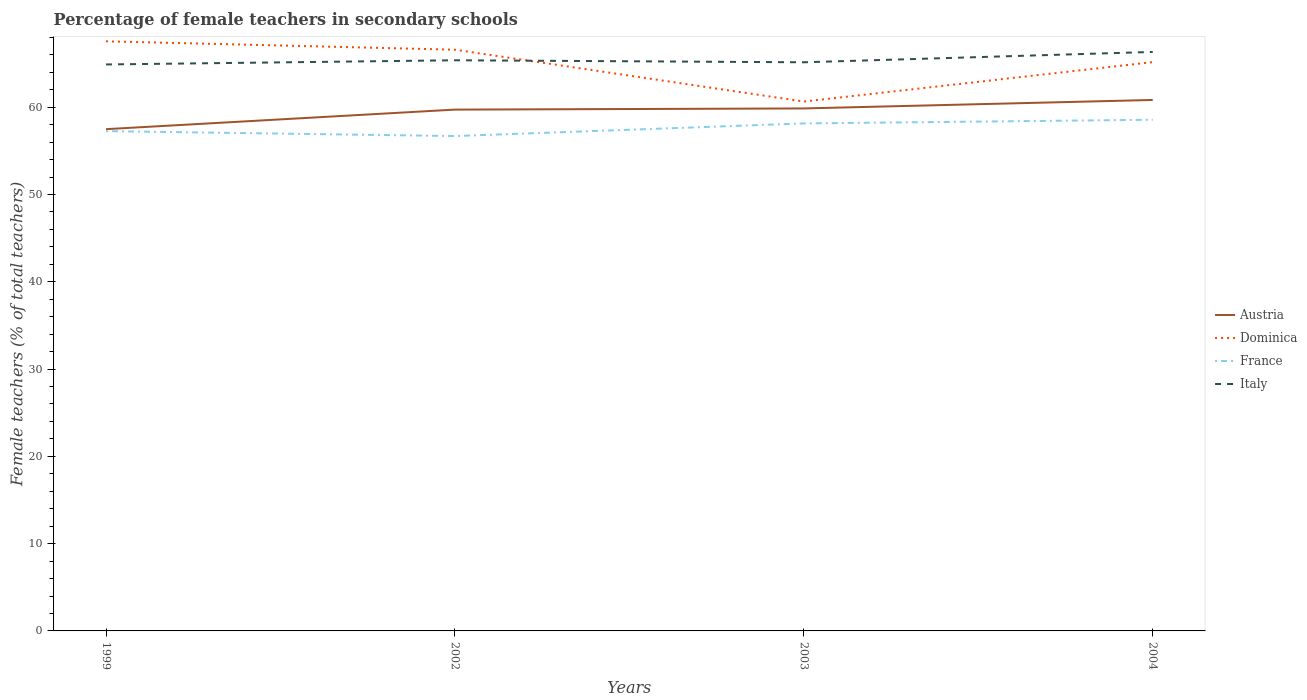Does the line corresponding to Dominica intersect with the line corresponding to Italy?
Make the answer very short. Yes. Across all years, what is the maximum percentage of female teachers in Italy?
Your response must be concise. 64.9. In which year was the percentage of female teachers in France maximum?
Your response must be concise. 2002. What is the total percentage of female teachers in France in the graph?
Ensure brevity in your answer.  -1.3. What is the difference between the highest and the second highest percentage of female teachers in France?
Ensure brevity in your answer.  1.87. Is the percentage of female teachers in Dominica strictly greater than the percentage of female teachers in Austria over the years?
Ensure brevity in your answer.  No. How many lines are there?
Keep it short and to the point. 4. Does the graph contain grids?
Ensure brevity in your answer.  No. Where does the legend appear in the graph?
Provide a short and direct response. Center right. How many legend labels are there?
Offer a very short reply. 4. What is the title of the graph?
Offer a very short reply. Percentage of female teachers in secondary schools. What is the label or title of the X-axis?
Make the answer very short. Years. What is the label or title of the Y-axis?
Ensure brevity in your answer.  Female teachers (% of total teachers). What is the Female teachers (% of total teachers) of Austria in 1999?
Ensure brevity in your answer.  57.49. What is the Female teachers (% of total teachers) of Dominica in 1999?
Provide a short and direct response. 67.55. What is the Female teachers (% of total teachers) in France in 1999?
Give a very brief answer. 57.26. What is the Female teachers (% of total teachers) in Italy in 1999?
Make the answer very short. 64.9. What is the Female teachers (% of total teachers) in Austria in 2002?
Give a very brief answer. 59.73. What is the Female teachers (% of total teachers) of Dominica in 2002?
Keep it short and to the point. 66.59. What is the Female teachers (% of total teachers) in France in 2002?
Your response must be concise. 56.7. What is the Female teachers (% of total teachers) of Italy in 2002?
Your answer should be very brief. 65.38. What is the Female teachers (% of total teachers) in Austria in 2003?
Make the answer very short. 59.86. What is the Female teachers (% of total teachers) in Dominica in 2003?
Make the answer very short. 60.65. What is the Female teachers (% of total teachers) in France in 2003?
Ensure brevity in your answer.  58.15. What is the Female teachers (% of total teachers) in Italy in 2003?
Your answer should be compact. 65.15. What is the Female teachers (% of total teachers) of Austria in 2004?
Your answer should be compact. 60.83. What is the Female teachers (% of total teachers) in Dominica in 2004?
Provide a succinct answer. 65.17. What is the Female teachers (% of total teachers) of France in 2004?
Ensure brevity in your answer.  58.57. What is the Female teachers (% of total teachers) of Italy in 2004?
Your answer should be compact. 66.34. Across all years, what is the maximum Female teachers (% of total teachers) of Austria?
Offer a terse response. 60.83. Across all years, what is the maximum Female teachers (% of total teachers) in Dominica?
Offer a very short reply. 67.55. Across all years, what is the maximum Female teachers (% of total teachers) of France?
Give a very brief answer. 58.57. Across all years, what is the maximum Female teachers (% of total teachers) in Italy?
Your response must be concise. 66.34. Across all years, what is the minimum Female teachers (% of total teachers) in Austria?
Provide a short and direct response. 57.49. Across all years, what is the minimum Female teachers (% of total teachers) of Dominica?
Offer a terse response. 60.65. Across all years, what is the minimum Female teachers (% of total teachers) in France?
Your response must be concise. 56.7. Across all years, what is the minimum Female teachers (% of total teachers) in Italy?
Your answer should be compact. 64.9. What is the total Female teachers (% of total teachers) in Austria in the graph?
Offer a terse response. 237.91. What is the total Female teachers (% of total teachers) in Dominica in the graph?
Provide a short and direct response. 259.97. What is the total Female teachers (% of total teachers) in France in the graph?
Provide a short and direct response. 230.67. What is the total Female teachers (% of total teachers) in Italy in the graph?
Provide a short and direct response. 261.77. What is the difference between the Female teachers (% of total teachers) of Austria in 1999 and that in 2002?
Provide a short and direct response. -2.24. What is the difference between the Female teachers (% of total teachers) of Dominica in 1999 and that in 2002?
Your answer should be very brief. 0.96. What is the difference between the Female teachers (% of total teachers) of France in 1999 and that in 2002?
Your response must be concise. 0.56. What is the difference between the Female teachers (% of total teachers) of Italy in 1999 and that in 2002?
Ensure brevity in your answer.  -0.48. What is the difference between the Female teachers (% of total teachers) of Austria in 1999 and that in 2003?
Provide a succinct answer. -2.37. What is the difference between the Female teachers (% of total teachers) in Dominica in 1999 and that in 2003?
Keep it short and to the point. 6.9. What is the difference between the Female teachers (% of total teachers) in France in 1999 and that in 2003?
Your answer should be very brief. -0.88. What is the difference between the Female teachers (% of total teachers) in Italy in 1999 and that in 2003?
Keep it short and to the point. -0.25. What is the difference between the Female teachers (% of total teachers) in Austria in 1999 and that in 2004?
Give a very brief answer. -3.35. What is the difference between the Female teachers (% of total teachers) in Dominica in 1999 and that in 2004?
Offer a very short reply. 2.38. What is the difference between the Female teachers (% of total teachers) of France in 1999 and that in 2004?
Make the answer very short. -1.3. What is the difference between the Female teachers (% of total teachers) of Italy in 1999 and that in 2004?
Your answer should be compact. -1.43. What is the difference between the Female teachers (% of total teachers) in Austria in 2002 and that in 2003?
Give a very brief answer. -0.13. What is the difference between the Female teachers (% of total teachers) of Dominica in 2002 and that in 2003?
Keep it short and to the point. 5.94. What is the difference between the Female teachers (% of total teachers) in France in 2002 and that in 2003?
Make the answer very short. -1.45. What is the difference between the Female teachers (% of total teachers) of Italy in 2002 and that in 2003?
Your response must be concise. 0.23. What is the difference between the Female teachers (% of total teachers) in Austria in 2002 and that in 2004?
Provide a short and direct response. -1.11. What is the difference between the Female teachers (% of total teachers) in Dominica in 2002 and that in 2004?
Provide a short and direct response. 1.42. What is the difference between the Female teachers (% of total teachers) of France in 2002 and that in 2004?
Provide a short and direct response. -1.87. What is the difference between the Female teachers (% of total teachers) of Italy in 2002 and that in 2004?
Offer a terse response. -0.96. What is the difference between the Female teachers (% of total teachers) of Austria in 2003 and that in 2004?
Your response must be concise. -0.97. What is the difference between the Female teachers (% of total teachers) in Dominica in 2003 and that in 2004?
Your answer should be very brief. -4.52. What is the difference between the Female teachers (% of total teachers) in France in 2003 and that in 2004?
Make the answer very short. -0.42. What is the difference between the Female teachers (% of total teachers) in Italy in 2003 and that in 2004?
Provide a succinct answer. -1.19. What is the difference between the Female teachers (% of total teachers) in Austria in 1999 and the Female teachers (% of total teachers) in Dominica in 2002?
Provide a succinct answer. -9.1. What is the difference between the Female teachers (% of total teachers) of Austria in 1999 and the Female teachers (% of total teachers) of France in 2002?
Offer a very short reply. 0.79. What is the difference between the Female teachers (% of total teachers) of Austria in 1999 and the Female teachers (% of total teachers) of Italy in 2002?
Give a very brief answer. -7.89. What is the difference between the Female teachers (% of total teachers) of Dominica in 1999 and the Female teachers (% of total teachers) of France in 2002?
Give a very brief answer. 10.85. What is the difference between the Female teachers (% of total teachers) of Dominica in 1999 and the Female teachers (% of total teachers) of Italy in 2002?
Make the answer very short. 2.17. What is the difference between the Female teachers (% of total teachers) of France in 1999 and the Female teachers (% of total teachers) of Italy in 2002?
Provide a short and direct response. -8.12. What is the difference between the Female teachers (% of total teachers) of Austria in 1999 and the Female teachers (% of total teachers) of Dominica in 2003?
Offer a very short reply. -3.16. What is the difference between the Female teachers (% of total teachers) of Austria in 1999 and the Female teachers (% of total teachers) of France in 2003?
Give a very brief answer. -0.66. What is the difference between the Female teachers (% of total teachers) of Austria in 1999 and the Female teachers (% of total teachers) of Italy in 2003?
Offer a terse response. -7.66. What is the difference between the Female teachers (% of total teachers) of Dominica in 1999 and the Female teachers (% of total teachers) of France in 2003?
Offer a very short reply. 9.41. What is the difference between the Female teachers (% of total teachers) in Dominica in 1999 and the Female teachers (% of total teachers) in Italy in 2003?
Offer a terse response. 2.4. What is the difference between the Female teachers (% of total teachers) in France in 1999 and the Female teachers (% of total teachers) in Italy in 2003?
Ensure brevity in your answer.  -7.89. What is the difference between the Female teachers (% of total teachers) in Austria in 1999 and the Female teachers (% of total teachers) in Dominica in 2004?
Offer a very short reply. -7.68. What is the difference between the Female teachers (% of total teachers) of Austria in 1999 and the Female teachers (% of total teachers) of France in 2004?
Your answer should be compact. -1.08. What is the difference between the Female teachers (% of total teachers) in Austria in 1999 and the Female teachers (% of total teachers) in Italy in 2004?
Make the answer very short. -8.85. What is the difference between the Female teachers (% of total teachers) in Dominica in 1999 and the Female teachers (% of total teachers) in France in 2004?
Keep it short and to the point. 8.99. What is the difference between the Female teachers (% of total teachers) in Dominica in 1999 and the Female teachers (% of total teachers) in Italy in 2004?
Offer a very short reply. 1.22. What is the difference between the Female teachers (% of total teachers) in France in 1999 and the Female teachers (% of total teachers) in Italy in 2004?
Your answer should be very brief. -9.07. What is the difference between the Female teachers (% of total teachers) in Austria in 2002 and the Female teachers (% of total teachers) in Dominica in 2003?
Make the answer very short. -0.92. What is the difference between the Female teachers (% of total teachers) of Austria in 2002 and the Female teachers (% of total teachers) of France in 2003?
Ensure brevity in your answer.  1.58. What is the difference between the Female teachers (% of total teachers) of Austria in 2002 and the Female teachers (% of total teachers) of Italy in 2003?
Make the answer very short. -5.42. What is the difference between the Female teachers (% of total teachers) of Dominica in 2002 and the Female teachers (% of total teachers) of France in 2003?
Keep it short and to the point. 8.45. What is the difference between the Female teachers (% of total teachers) in Dominica in 2002 and the Female teachers (% of total teachers) in Italy in 2003?
Offer a terse response. 1.44. What is the difference between the Female teachers (% of total teachers) in France in 2002 and the Female teachers (% of total teachers) in Italy in 2003?
Offer a very short reply. -8.45. What is the difference between the Female teachers (% of total teachers) in Austria in 2002 and the Female teachers (% of total teachers) in Dominica in 2004?
Your answer should be very brief. -5.44. What is the difference between the Female teachers (% of total teachers) in Austria in 2002 and the Female teachers (% of total teachers) in France in 2004?
Keep it short and to the point. 1.16. What is the difference between the Female teachers (% of total teachers) in Austria in 2002 and the Female teachers (% of total teachers) in Italy in 2004?
Your answer should be compact. -6.61. What is the difference between the Female teachers (% of total teachers) in Dominica in 2002 and the Female teachers (% of total teachers) in France in 2004?
Provide a succinct answer. 8.03. What is the difference between the Female teachers (% of total teachers) of Dominica in 2002 and the Female teachers (% of total teachers) of Italy in 2004?
Give a very brief answer. 0.26. What is the difference between the Female teachers (% of total teachers) in France in 2002 and the Female teachers (% of total teachers) in Italy in 2004?
Your answer should be very brief. -9.64. What is the difference between the Female teachers (% of total teachers) of Austria in 2003 and the Female teachers (% of total teachers) of Dominica in 2004?
Make the answer very short. -5.31. What is the difference between the Female teachers (% of total teachers) in Austria in 2003 and the Female teachers (% of total teachers) in France in 2004?
Your response must be concise. 1.3. What is the difference between the Female teachers (% of total teachers) in Austria in 2003 and the Female teachers (% of total teachers) in Italy in 2004?
Your response must be concise. -6.47. What is the difference between the Female teachers (% of total teachers) of Dominica in 2003 and the Female teachers (% of total teachers) of France in 2004?
Your response must be concise. 2.09. What is the difference between the Female teachers (% of total teachers) in Dominica in 2003 and the Female teachers (% of total teachers) in Italy in 2004?
Your answer should be very brief. -5.68. What is the difference between the Female teachers (% of total teachers) in France in 2003 and the Female teachers (% of total teachers) in Italy in 2004?
Give a very brief answer. -8.19. What is the average Female teachers (% of total teachers) of Austria per year?
Your response must be concise. 59.48. What is the average Female teachers (% of total teachers) of Dominica per year?
Your answer should be compact. 64.99. What is the average Female teachers (% of total teachers) of France per year?
Your response must be concise. 57.67. What is the average Female teachers (% of total teachers) of Italy per year?
Keep it short and to the point. 65.44. In the year 1999, what is the difference between the Female teachers (% of total teachers) of Austria and Female teachers (% of total teachers) of Dominica?
Provide a short and direct response. -10.07. In the year 1999, what is the difference between the Female teachers (% of total teachers) in Austria and Female teachers (% of total teachers) in France?
Keep it short and to the point. 0.23. In the year 1999, what is the difference between the Female teachers (% of total teachers) of Austria and Female teachers (% of total teachers) of Italy?
Your response must be concise. -7.41. In the year 1999, what is the difference between the Female teachers (% of total teachers) in Dominica and Female teachers (% of total teachers) in France?
Your answer should be compact. 10.29. In the year 1999, what is the difference between the Female teachers (% of total teachers) in Dominica and Female teachers (% of total teachers) in Italy?
Your answer should be compact. 2.65. In the year 1999, what is the difference between the Female teachers (% of total teachers) of France and Female teachers (% of total teachers) of Italy?
Your answer should be very brief. -7.64. In the year 2002, what is the difference between the Female teachers (% of total teachers) of Austria and Female teachers (% of total teachers) of Dominica?
Your answer should be very brief. -6.86. In the year 2002, what is the difference between the Female teachers (% of total teachers) in Austria and Female teachers (% of total teachers) in France?
Your answer should be very brief. 3.03. In the year 2002, what is the difference between the Female teachers (% of total teachers) of Austria and Female teachers (% of total teachers) of Italy?
Your answer should be compact. -5.65. In the year 2002, what is the difference between the Female teachers (% of total teachers) in Dominica and Female teachers (% of total teachers) in France?
Your answer should be compact. 9.89. In the year 2002, what is the difference between the Female teachers (% of total teachers) of Dominica and Female teachers (% of total teachers) of Italy?
Make the answer very short. 1.21. In the year 2002, what is the difference between the Female teachers (% of total teachers) in France and Female teachers (% of total teachers) in Italy?
Your answer should be very brief. -8.68. In the year 2003, what is the difference between the Female teachers (% of total teachers) in Austria and Female teachers (% of total teachers) in Dominica?
Make the answer very short. -0.79. In the year 2003, what is the difference between the Female teachers (% of total teachers) in Austria and Female teachers (% of total teachers) in France?
Make the answer very short. 1.72. In the year 2003, what is the difference between the Female teachers (% of total teachers) of Austria and Female teachers (% of total teachers) of Italy?
Provide a short and direct response. -5.29. In the year 2003, what is the difference between the Female teachers (% of total teachers) of Dominica and Female teachers (% of total teachers) of France?
Provide a short and direct response. 2.51. In the year 2003, what is the difference between the Female teachers (% of total teachers) of Dominica and Female teachers (% of total teachers) of Italy?
Your answer should be very brief. -4.5. In the year 2003, what is the difference between the Female teachers (% of total teachers) of France and Female teachers (% of total teachers) of Italy?
Keep it short and to the point. -7. In the year 2004, what is the difference between the Female teachers (% of total teachers) in Austria and Female teachers (% of total teachers) in Dominica?
Offer a terse response. -4.33. In the year 2004, what is the difference between the Female teachers (% of total teachers) in Austria and Female teachers (% of total teachers) in France?
Offer a terse response. 2.27. In the year 2004, what is the difference between the Female teachers (% of total teachers) in Austria and Female teachers (% of total teachers) in Italy?
Provide a short and direct response. -5.5. In the year 2004, what is the difference between the Female teachers (% of total teachers) in Dominica and Female teachers (% of total teachers) in France?
Your response must be concise. 6.6. In the year 2004, what is the difference between the Female teachers (% of total teachers) of Dominica and Female teachers (% of total teachers) of Italy?
Keep it short and to the point. -1.17. In the year 2004, what is the difference between the Female teachers (% of total teachers) in France and Female teachers (% of total teachers) in Italy?
Keep it short and to the point. -7.77. What is the ratio of the Female teachers (% of total teachers) of Austria in 1999 to that in 2002?
Offer a terse response. 0.96. What is the ratio of the Female teachers (% of total teachers) in Dominica in 1999 to that in 2002?
Your answer should be compact. 1.01. What is the ratio of the Female teachers (% of total teachers) in France in 1999 to that in 2002?
Provide a succinct answer. 1.01. What is the ratio of the Female teachers (% of total teachers) of Italy in 1999 to that in 2002?
Your answer should be very brief. 0.99. What is the ratio of the Female teachers (% of total teachers) of Austria in 1999 to that in 2003?
Ensure brevity in your answer.  0.96. What is the ratio of the Female teachers (% of total teachers) in Dominica in 1999 to that in 2003?
Provide a short and direct response. 1.11. What is the ratio of the Female teachers (% of total teachers) of France in 1999 to that in 2003?
Your answer should be compact. 0.98. What is the ratio of the Female teachers (% of total teachers) in Austria in 1999 to that in 2004?
Keep it short and to the point. 0.94. What is the ratio of the Female teachers (% of total teachers) of Dominica in 1999 to that in 2004?
Your answer should be compact. 1.04. What is the ratio of the Female teachers (% of total teachers) of France in 1999 to that in 2004?
Make the answer very short. 0.98. What is the ratio of the Female teachers (% of total teachers) of Italy in 1999 to that in 2004?
Offer a terse response. 0.98. What is the ratio of the Female teachers (% of total teachers) in Dominica in 2002 to that in 2003?
Provide a succinct answer. 1.1. What is the ratio of the Female teachers (% of total teachers) of France in 2002 to that in 2003?
Offer a very short reply. 0.98. What is the ratio of the Female teachers (% of total teachers) in Italy in 2002 to that in 2003?
Ensure brevity in your answer.  1. What is the ratio of the Female teachers (% of total teachers) of Austria in 2002 to that in 2004?
Offer a terse response. 0.98. What is the ratio of the Female teachers (% of total teachers) of Dominica in 2002 to that in 2004?
Make the answer very short. 1.02. What is the ratio of the Female teachers (% of total teachers) of France in 2002 to that in 2004?
Make the answer very short. 0.97. What is the ratio of the Female teachers (% of total teachers) in Italy in 2002 to that in 2004?
Your answer should be compact. 0.99. What is the ratio of the Female teachers (% of total teachers) in Austria in 2003 to that in 2004?
Provide a succinct answer. 0.98. What is the ratio of the Female teachers (% of total teachers) in Dominica in 2003 to that in 2004?
Offer a terse response. 0.93. What is the ratio of the Female teachers (% of total teachers) in France in 2003 to that in 2004?
Provide a short and direct response. 0.99. What is the ratio of the Female teachers (% of total teachers) of Italy in 2003 to that in 2004?
Provide a short and direct response. 0.98. What is the difference between the highest and the second highest Female teachers (% of total teachers) in Austria?
Ensure brevity in your answer.  0.97. What is the difference between the highest and the second highest Female teachers (% of total teachers) in Dominica?
Make the answer very short. 0.96. What is the difference between the highest and the second highest Female teachers (% of total teachers) of France?
Your response must be concise. 0.42. What is the difference between the highest and the second highest Female teachers (% of total teachers) in Italy?
Provide a short and direct response. 0.96. What is the difference between the highest and the lowest Female teachers (% of total teachers) of Austria?
Your answer should be compact. 3.35. What is the difference between the highest and the lowest Female teachers (% of total teachers) of Dominica?
Offer a very short reply. 6.9. What is the difference between the highest and the lowest Female teachers (% of total teachers) in France?
Make the answer very short. 1.87. What is the difference between the highest and the lowest Female teachers (% of total teachers) in Italy?
Provide a succinct answer. 1.43. 